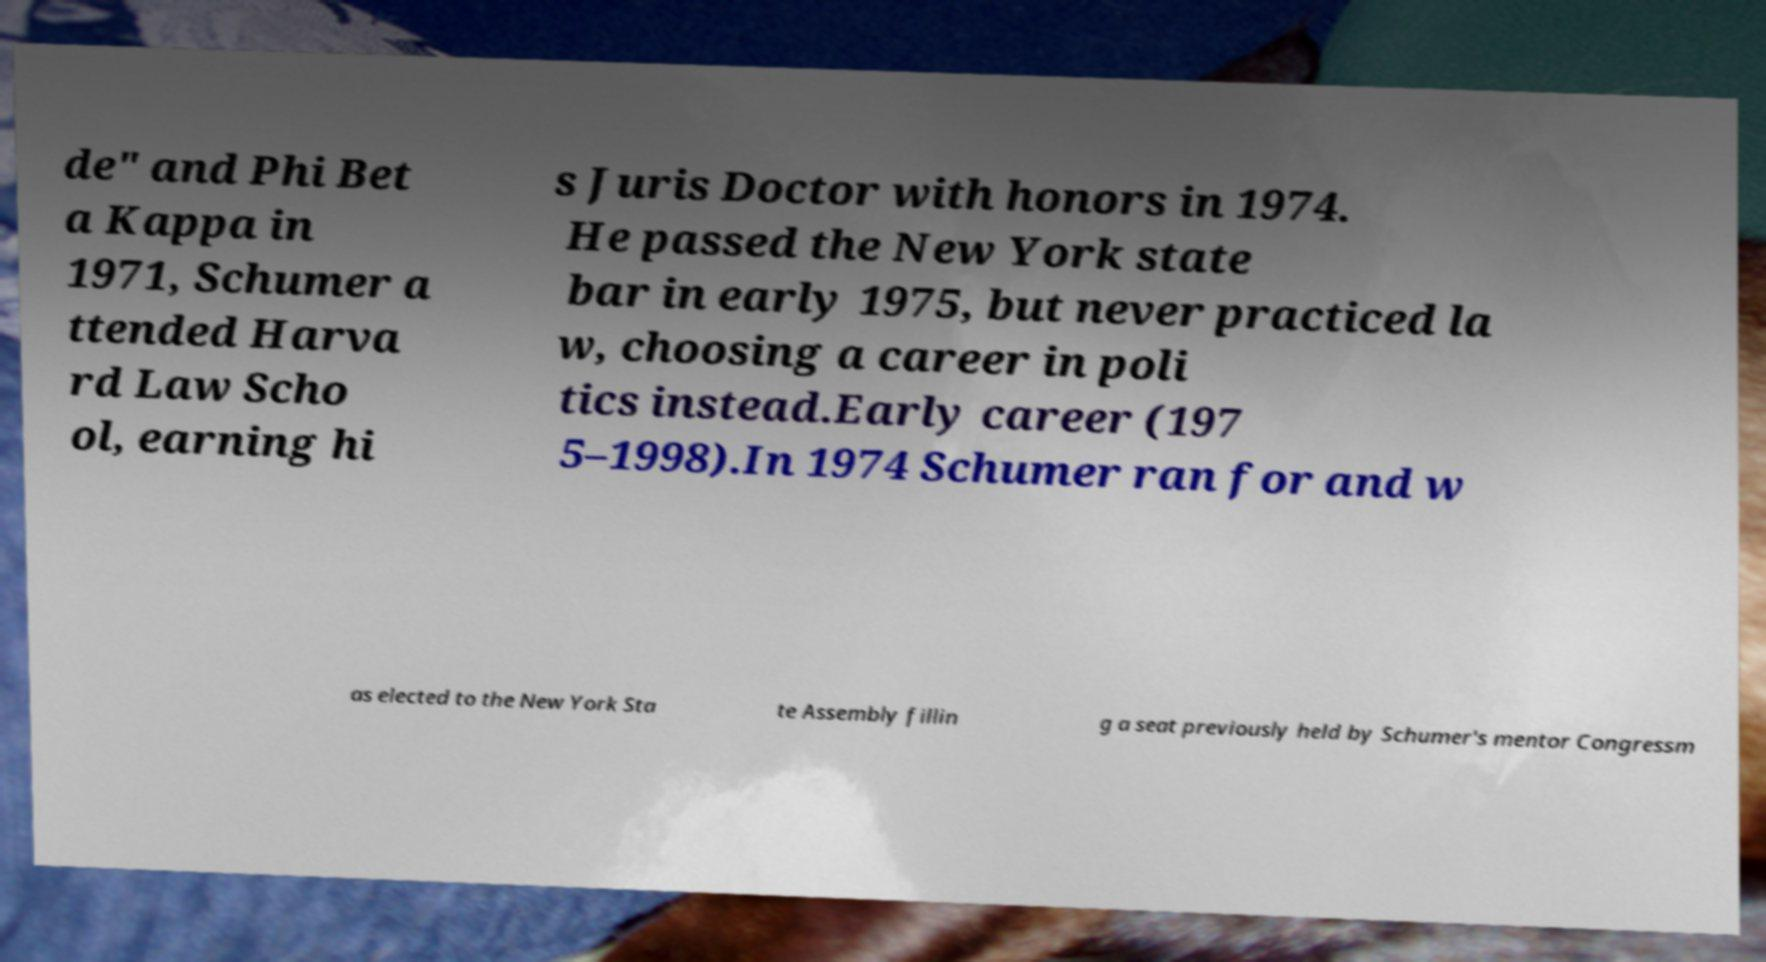There's text embedded in this image that I need extracted. Can you transcribe it verbatim? de" and Phi Bet a Kappa in 1971, Schumer a ttended Harva rd Law Scho ol, earning hi s Juris Doctor with honors in 1974. He passed the New York state bar in early 1975, but never practiced la w, choosing a career in poli tics instead.Early career (197 5–1998).In 1974 Schumer ran for and w as elected to the New York Sta te Assembly fillin g a seat previously held by Schumer's mentor Congressm 